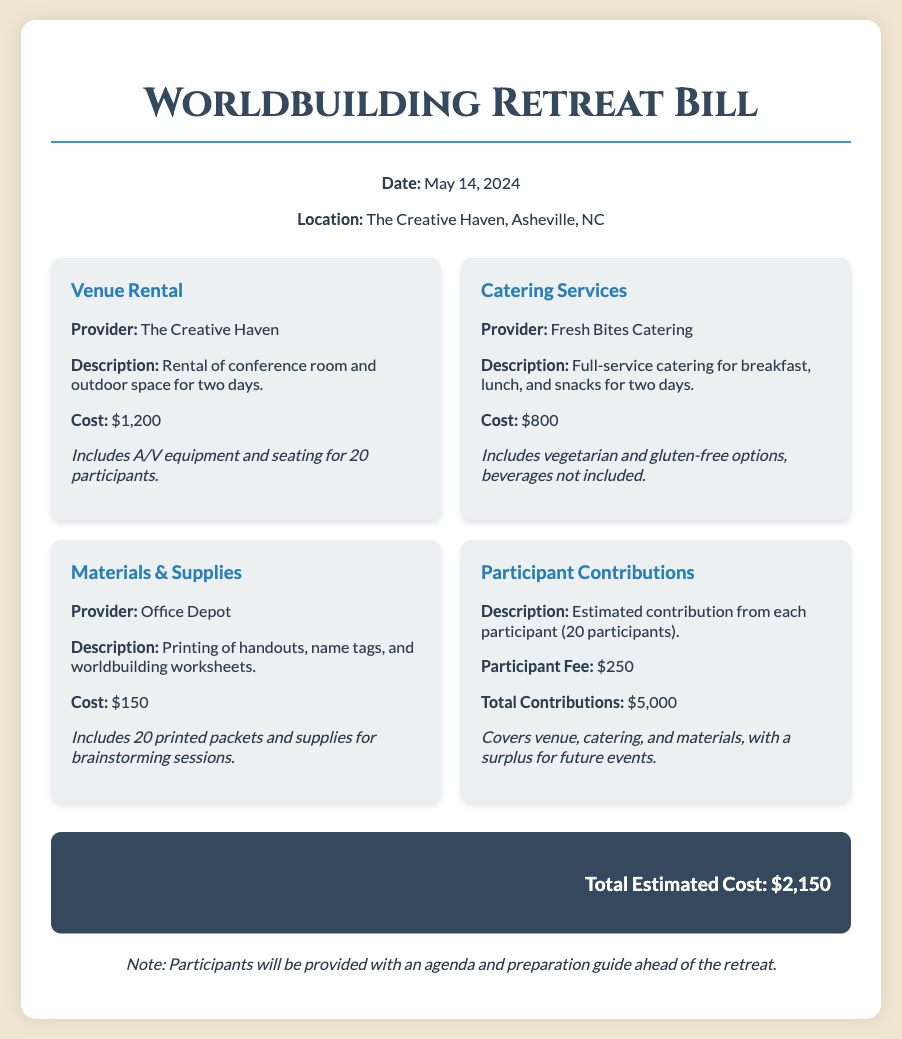What is the date of the retreat? The date of the retreat is mentioned clearly in the event information section of the document.
Answer: May 14, 2024 What is the total estimated cost? The total estimated cost is summarized at the end of the bill, reflecting the overall expenses for the event.
Answer: $2,150 How many participants are expected? The document states that there are 20 participants contributing to the event costs.
Answer: 20 Who provides the catering services? The catering service provider is identified in the cost breakdown section of the bill.
Answer: Fresh Bites Catering What is included in the venue rental? The description for the venue rental outlines specific details about rentals, including equipment.
Answer: A/V equipment and seating for 20 participants What is the participant fee? The document specifies the amount each participant is expected to contribute towards the retreat costs.
Answer: $250 How much does the catering service cost? The cost of catering services is listed in the breakdown section for clarity.
Answer: $800 What is the purpose of the participant contributions? The role of contributions is described in the context of covering costs while also planning for future events.
Answer: Covers venue, catering, and materials What type of materials were printed? The description for materials & supplies outlines what was produced for the event.
Answer: Handouts, name tags, and worldbuilding worksheets 